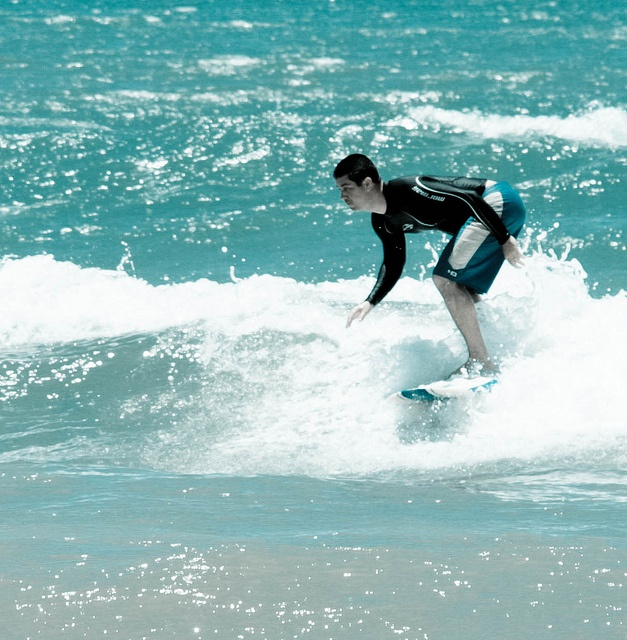Describe the objects in this image and their specific colors. I can see people in teal, black, darkgray, gray, and lightgray tones and surfboard in teal, white, and lightblue tones in this image. 